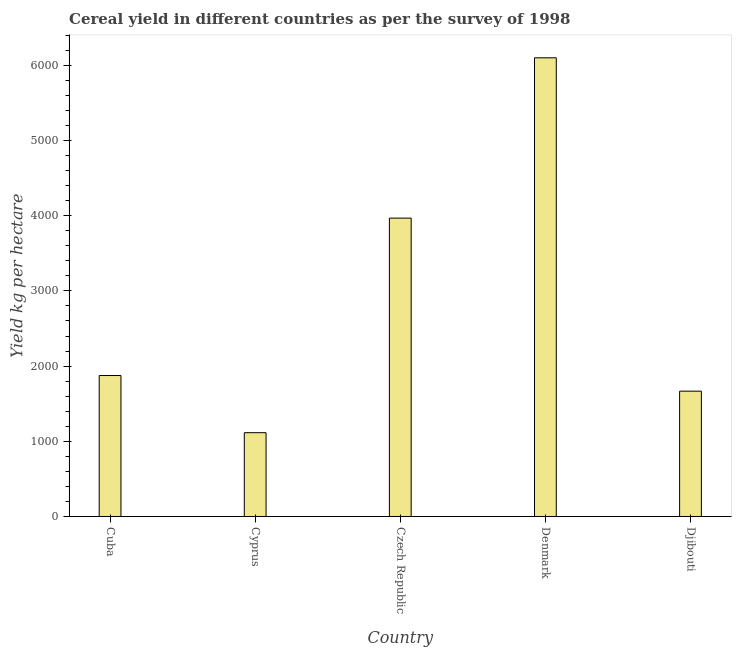Does the graph contain grids?
Make the answer very short. No. What is the title of the graph?
Make the answer very short. Cereal yield in different countries as per the survey of 1998. What is the label or title of the Y-axis?
Provide a short and direct response. Yield kg per hectare. What is the cereal yield in Denmark?
Make the answer very short. 6100.08. Across all countries, what is the maximum cereal yield?
Provide a succinct answer. 6100.08. Across all countries, what is the minimum cereal yield?
Keep it short and to the point. 1114.4. In which country was the cereal yield maximum?
Provide a succinct answer. Denmark. In which country was the cereal yield minimum?
Make the answer very short. Cyprus. What is the sum of the cereal yield?
Your response must be concise. 1.47e+04. What is the difference between the cereal yield in Czech Republic and Djibouti?
Your answer should be very brief. 2301.43. What is the average cereal yield per country?
Provide a short and direct response. 2944.79. What is the median cereal yield?
Your response must be concise. 1874.71. What is the ratio of the cereal yield in Cyprus to that in Czech Republic?
Keep it short and to the point. 0.28. Is the cereal yield in Cyprus less than that in Czech Republic?
Provide a short and direct response. Yes. What is the difference between the highest and the second highest cereal yield?
Ensure brevity in your answer.  2131.99. Is the sum of the cereal yield in Cyprus and Czech Republic greater than the maximum cereal yield across all countries?
Provide a succinct answer. No. What is the difference between the highest and the lowest cereal yield?
Offer a terse response. 4985.68. How many bars are there?
Your answer should be compact. 5. Are all the bars in the graph horizontal?
Your answer should be compact. No. Are the values on the major ticks of Y-axis written in scientific E-notation?
Your answer should be compact. No. What is the Yield kg per hectare of Cuba?
Offer a very short reply. 1874.71. What is the Yield kg per hectare of Cyprus?
Provide a short and direct response. 1114.4. What is the Yield kg per hectare of Czech Republic?
Keep it short and to the point. 3968.1. What is the Yield kg per hectare of Denmark?
Your response must be concise. 6100.08. What is the Yield kg per hectare of Djibouti?
Offer a terse response. 1666.67. What is the difference between the Yield kg per hectare in Cuba and Cyprus?
Offer a very short reply. 760.31. What is the difference between the Yield kg per hectare in Cuba and Czech Republic?
Offer a terse response. -2093.39. What is the difference between the Yield kg per hectare in Cuba and Denmark?
Offer a terse response. -4225.37. What is the difference between the Yield kg per hectare in Cuba and Djibouti?
Your answer should be compact. 208.04. What is the difference between the Yield kg per hectare in Cyprus and Czech Republic?
Make the answer very short. -2853.69. What is the difference between the Yield kg per hectare in Cyprus and Denmark?
Your answer should be very brief. -4985.68. What is the difference between the Yield kg per hectare in Cyprus and Djibouti?
Provide a short and direct response. -552.26. What is the difference between the Yield kg per hectare in Czech Republic and Denmark?
Keep it short and to the point. -2131.99. What is the difference between the Yield kg per hectare in Czech Republic and Djibouti?
Provide a succinct answer. 2301.43. What is the difference between the Yield kg per hectare in Denmark and Djibouti?
Your response must be concise. 4433.41. What is the ratio of the Yield kg per hectare in Cuba to that in Cyprus?
Your response must be concise. 1.68. What is the ratio of the Yield kg per hectare in Cuba to that in Czech Republic?
Make the answer very short. 0.47. What is the ratio of the Yield kg per hectare in Cuba to that in Denmark?
Offer a very short reply. 0.31. What is the ratio of the Yield kg per hectare in Cyprus to that in Czech Republic?
Your response must be concise. 0.28. What is the ratio of the Yield kg per hectare in Cyprus to that in Denmark?
Make the answer very short. 0.18. What is the ratio of the Yield kg per hectare in Cyprus to that in Djibouti?
Offer a terse response. 0.67. What is the ratio of the Yield kg per hectare in Czech Republic to that in Denmark?
Your answer should be very brief. 0.65. What is the ratio of the Yield kg per hectare in Czech Republic to that in Djibouti?
Give a very brief answer. 2.38. What is the ratio of the Yield kg per hectare in Denmark to that in Djibouti?
Your answer should be compact. 3.66. 